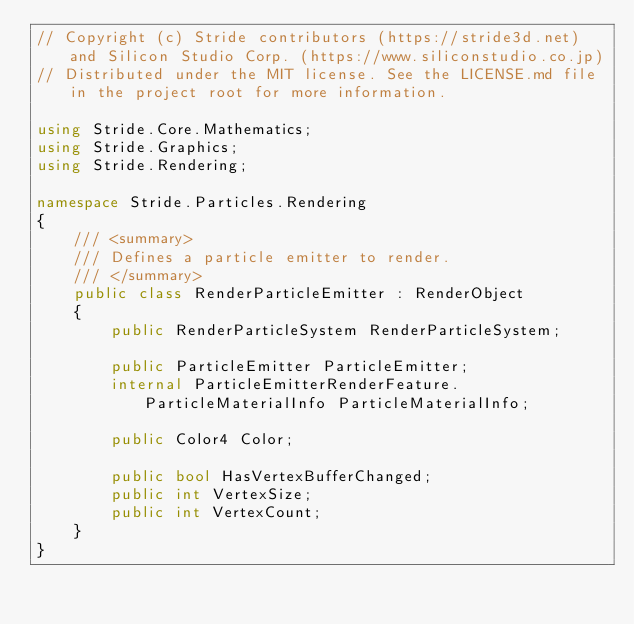<code> <loc_0><loc_0><loc_500><loc_500><_C#_>// Copyright (c) Stride contributors (https://stride3d.net) and Silicon Studio Corp. (https://www.siliconstudio.co.jp)
// Distributed under the MIT license. See the LICENSE.md file in the project root for more information.

using Stride.Core.Mathematics;
using Stride.Graphics;
using Stride.Rendering;

namespace Stride.Particles.Rendering
{
    /// <summary>
    /// Defines a particle emitter to render.
    /// </summary>
    public class RenderParticleEmitter : RenderObject
    {
        public RenderParticleSystem RenderParticleSystem;

        public ParticleEmitter ParticleEmitter;
        internal ParticleEmitterRenderFeature.ParticleMaterialInfo ParticleMaterialInfo;

        public Color4 Color;

        public bool HasVertexBufferChanged;
        public int VertexSize;
        public int VertexCount;
    }
}
</code> 